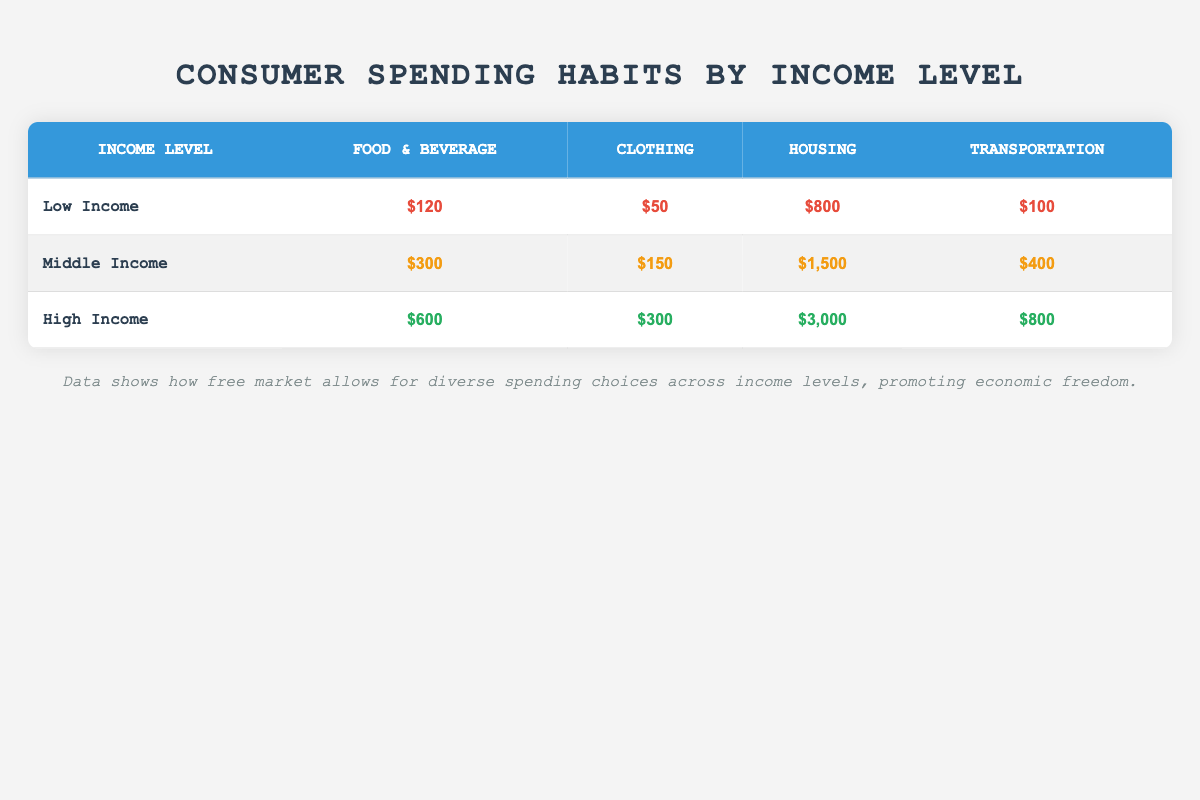What is the average spending on Food & Beverage across all income levels? To find the average spending on Food & Beverage, we add the spending amounts for all income levels: $120 (Low) + $300 (Middle) + $600 (High) = $1020. There are 3 income levels, so we divide the total by 3: $1020 / 3 = $340.
Answer: 340 Which income group spends the most on Housing? Looking at the Housing column, the spending amounts are $800 (Low), $1500 (Middle), and $3000 (High). The highest spending amount is $3000, associated with the High Income group.
Answer: High Income Is it true that Middle Income consumers spend more on Clothing than Low Income consumers? Comparing the Clothing spending amounts: Middle Income spends $150 while Low Income spends $50. Since $150 is greater than $50, the statement is true.
Answer: Yes What is the total average spending on Transportation for Low Income and Middle Income combined? The spending for Transportation is $100 (Low) and $400 (Middle). We first add these amounts: $100 + $400 = $500. To find the average for the two groups, we divide by 2: $500 / 2 = $250.
Answer: 250 How much more does a High Income consumer spend on Housing compared to a Low Income consumer? The Housing spending for High Income is $3000 and for Low Income, it is $800. We calculate the difference by subtracting the Low Income amount from the High Income amount: $3000 - $800 = $2200.
Answer: 2200 